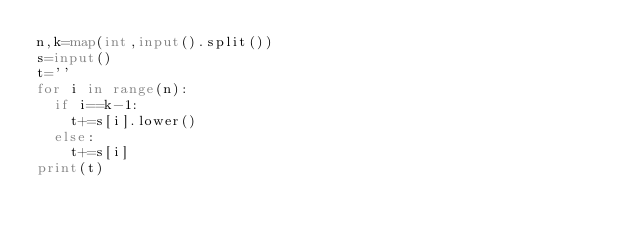Convert code to text. <code><loc_0><loc_0><loc_500><loc_500><_Python_>n,k=map(int,input().split())
s=input()
t=''
for i in range(n):
  if i==k-1:
    t+=s[i].lower()
  else:
    t+=s[i]
print(t)</code> 